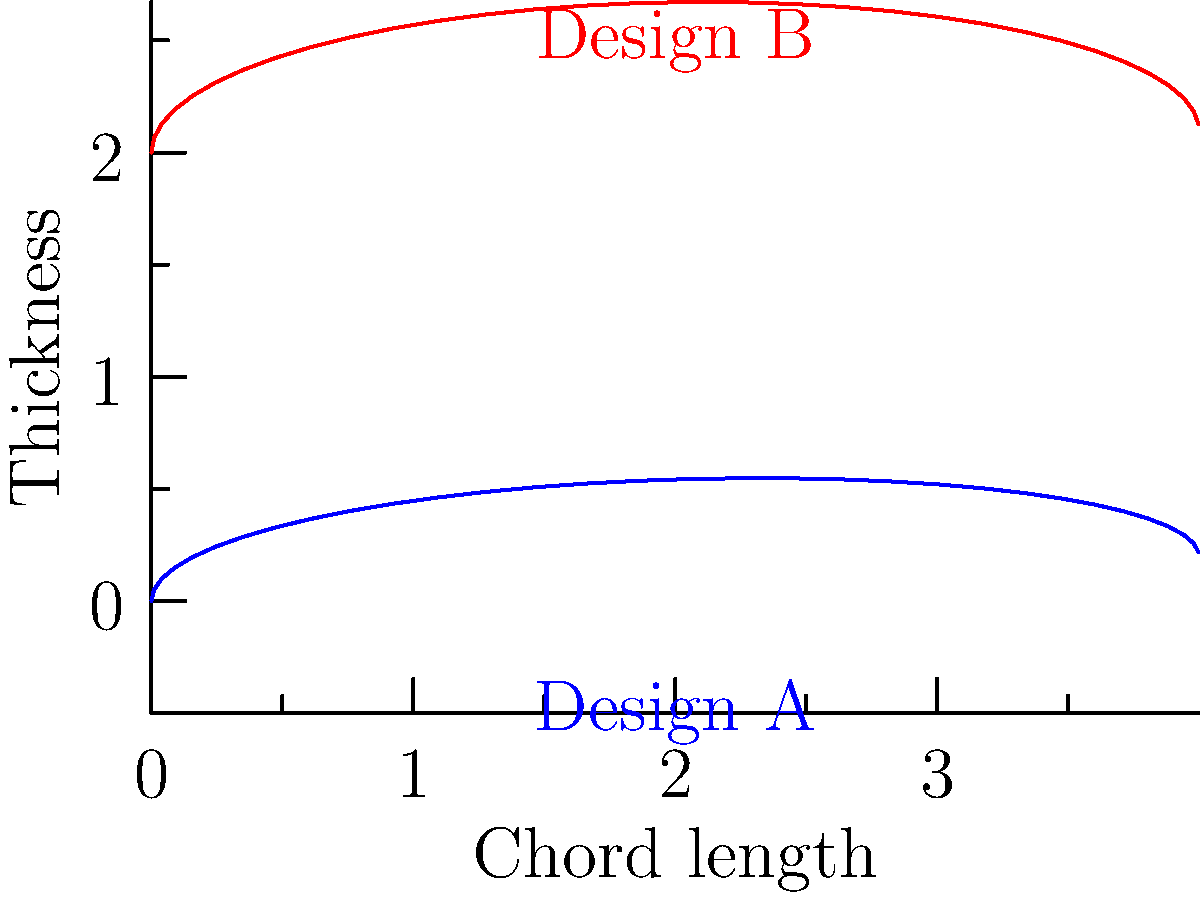Consider the two turbine blade designs shown in the airfoil cross-section diagrams. Design A (blue) has a thinner profile and higher camber, while Design B (red) has a thicker profile and lower camber. Based on these characteristics, which design would likely be more efficient for low-speed wind turbines operating in regions with historically lower technological development? To answer this question, we need to consider the following factors:

1. Blade thickness: 
   - Design A has a thinner profile
   - Design B has a thicker profile

2. Camber (curvature):
   - Design A has higher camber
   - Design B has lower camber

3. Low-speed wind turbines:
   - Operate at lower Reynolds numbers
   - Require higher lift coefficients

4. Historical context of lower technological development:
   - Simpler manufacturing processes
   - Less precise tolerances

Step-by-step analysis:

1. For low-speed wind turbines, higher lift coefficients are desirable to maximize energy extraction from the wind.
2. Higher camber generally produces higher lift coefficients at low speeds, favoring Design A.
3. Thinner airfoils typically have lower drag at low Reynolds numbers, again favoring Design A.
4. However, thicker airfoils (like Design B) are structurally stronger and easier to manufacture with less advanced technology.
5. The higher camber of Design A might be more challenging to produce accurately in regions with lower technological development.
6. Design B's thicker profile would be more forgiving of manufacturing imprecisions and more durable in harsh conditions.

Considering the balance between aerodynamic efficiency and practical constraints in less developed regions, Design B would likely be more efficient overall for this specific context.
Answer: Design B (thicker profile, lower camber) 